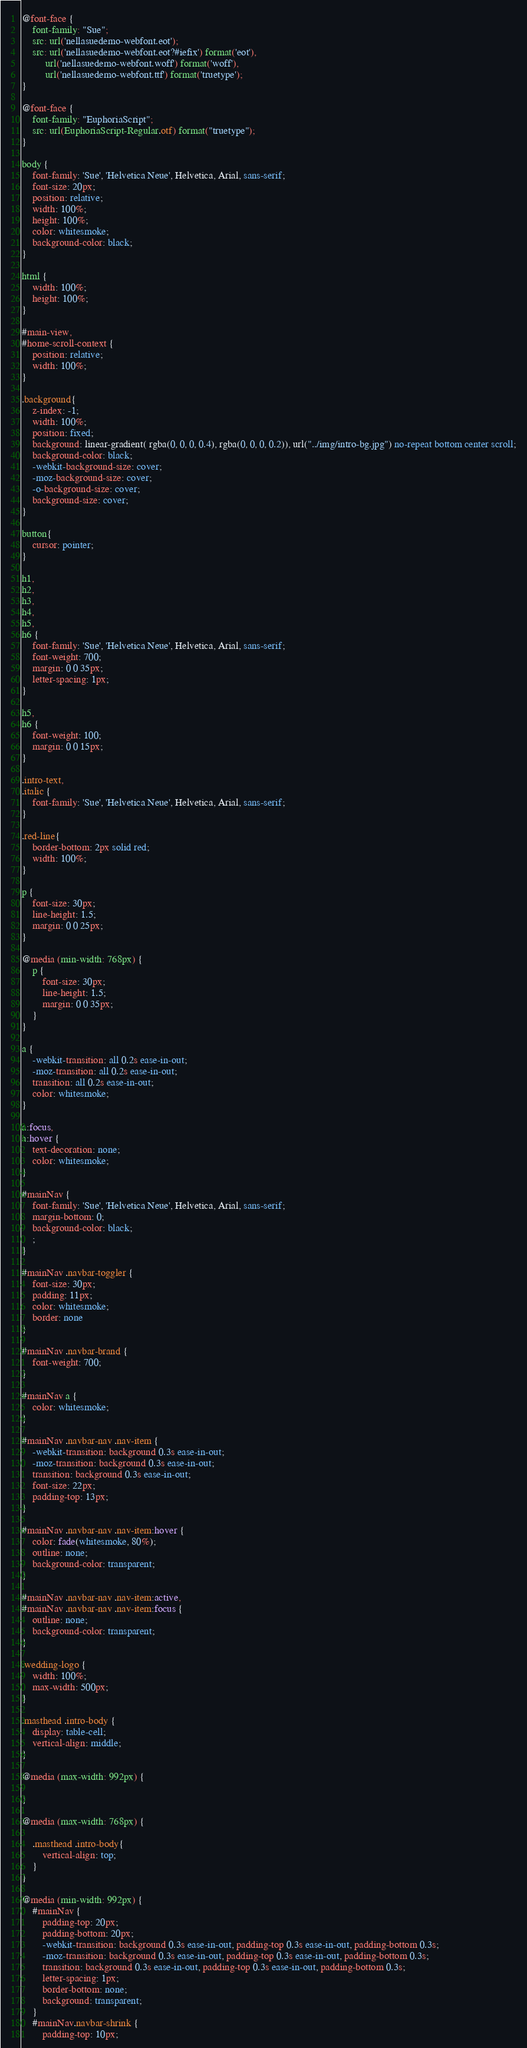Convert code to text. <code><loc_0><loc_0><loc_500><loc_500><_CSS_>@font-face {
    font-family: "Sue";
    src: url('nellasuedemo-webfont.eot');
    src: url('nellasuedemo-webfont.eot?#iefix') format('eot'),
         url('nellasuedemo-webfont.woff') format('woff'),
         url('nellasuedemo-webfont.ttf') format('truetype');
}

@font-face {
    font-family: "EuphoriaScript";
    src: url(EuphoriaScript-Regular.otf) format("truetype");
}

body {
    font-family: 'Sue', 'Helvetica Neue', Helvetica, Arial, sans-serif;
    font-size: 20px;
    position: relative;
    width: 100%;
    height: 100%;
    color: whitesmoke;
    background-color: black;
}

html {
    width: 100%;
    height: 100%;
}

#main-view,
#home-scroll-context {
    position: relative;
    width: 100%;
}

.background{
    z-index: -1;
    width: 100%;
    position: fixed;
    background: linear-gradient( rgba(0, 0, 0, 0.4), rgba(0, 0, 0, 0.2)), url("../img/intro-bg.jpg") no-repeat bottom center scroll;
    background-color: black;
    -webkit-background-size: cover;
    -moz-background-size: cover;
    -o-background-size: cover;
    background-size: cover;
}

button{
    cursor: pointer;
}

h1,
h2,
h3,
h4,
h5,
h6 {
    font-family: 'Sue', 'Helvetica Neue', Helvetica, Arial, sans-serif;
    font-weight: 700;
    margin: 0 0 35px;
    letter-spacing: 1px;
}

h5,
h6 {
    font-weight: 100;
    margin: 0 0 15px;
}

.intro-text,
.italic {
    font-family: 'Sue', 'Helvetica Neue', Helvetica, Arial, sans-serif;
}

.red-line{
    border-bottom: 2px solid red;
    width: 100%;
}

p {
    font-size: 30px;
    line-height: 1.5;
    margin: 0 0 25px;
}

@media (min-width: 768px) {
    p {
        font-size: 30px;
        line-height: 1.5;
        margin: 0 0 35px;
    }
}

a {
    -webkit-transition: all 0.2s ease-in-out;
    -moz-transition: all 0.2s ease-in-out;
    transition: all 0.2s ease-in-out;
    color: whitesmoke;
}

a:focus,
a:hover {
    text-decoration: none;
    color: whitesmoke;
}

#mainNav {
    font-family: 'Sue', 'Helvetica Neue', Helvetica, Arial, sans-serif;
    margin-bottom: 0;
    background-color: black;
    ;
}

#mainNav .navbar-toggler {
    font-size: 30px;
    padding: 11px;
    color: whitesmoke;
    border: none
}

#mainNav .navbar-brand {
    font-weight: 700;
}

#mainNav a {
    color: whitesmoke;
}

#mainNav .navbar-nav .nav-item {
    -webkit-transition: background 0.3s ease-in-out;
    -moz-transition: background 0.3s ease-in-out;
    transition: background 0.3s ease-in-out;
    font-size: 22px;
    padding-top: 13px;
}

#mainNav .navbar-nav .nav-item:hover {
    color: fade(whitesmoke, 80%);
    outline: none;
    background-color: transparent;
}

#mainNav .navbar-nav .nav-item:active,
#mainNav .navbar-nav .nav-item:focus {
    outline: none;
    background-color: transparent;
}

.wedding-logo {
    width: 100%;
    max-width: 500px;
}

.masthead .intro-body {
    display: table-cell;
    vertical-align: middle;
}

@media (max-width: 992px) {

}

@media (max-width: 768px) {

    .masthead .intro-body{
        vertical-align: top;
    }
}

@media (min-width: 992px) {
    #mainNav {
        padding-top: 20px;
        padding-bottom: 20px;
        -webkit-transition: background 0.3s ease-in-out, padding-top 0.3s ease-in-out, padding-bottom 0.3s;
        -moz-transition: background 0.3s ease-in-out, padding-top 0.3s ease-in-out, padding-bottom 0.3s;
        transition: background 0.3s ease-in-out, padding-top 0.3s ease-in-out, padding-bottom 0.3s;
        letter-spacing: 1px;
        border-bottom: none;
        background: transparent;
    }
    #mainNav.navbar-shrink {
        padding-top: 10px;</code> 